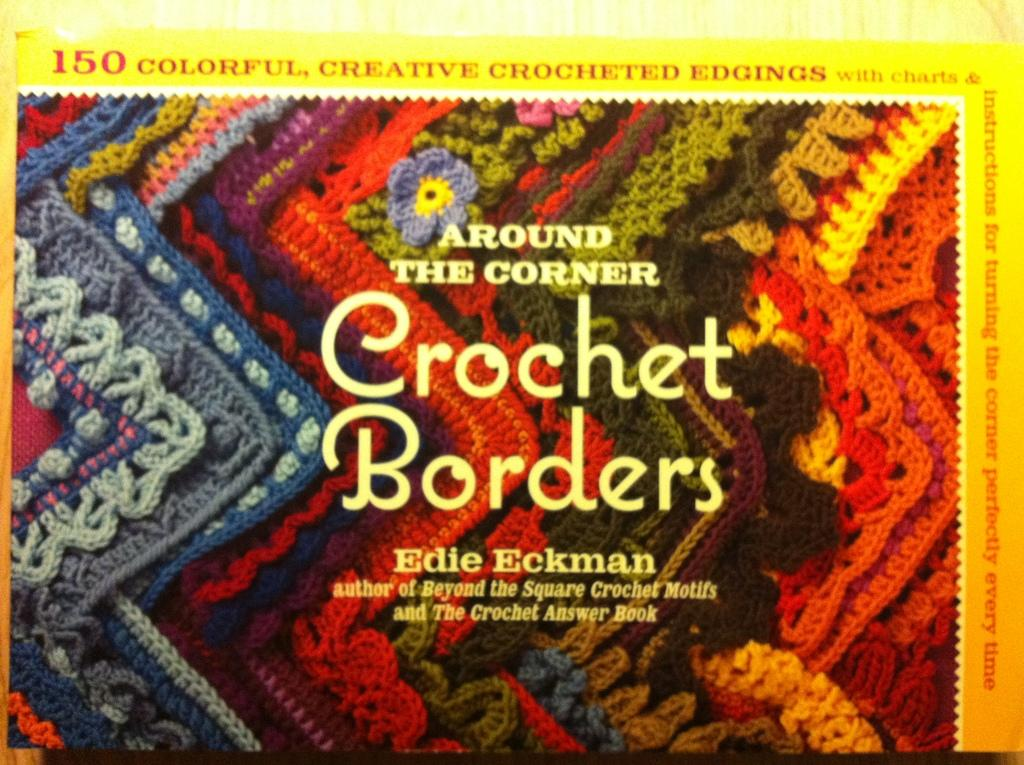Provide a one-sentence caption for the provided image. A SEWING BOOK CALLED CROCHET BORDERS BY EDIE ECKMAN. 